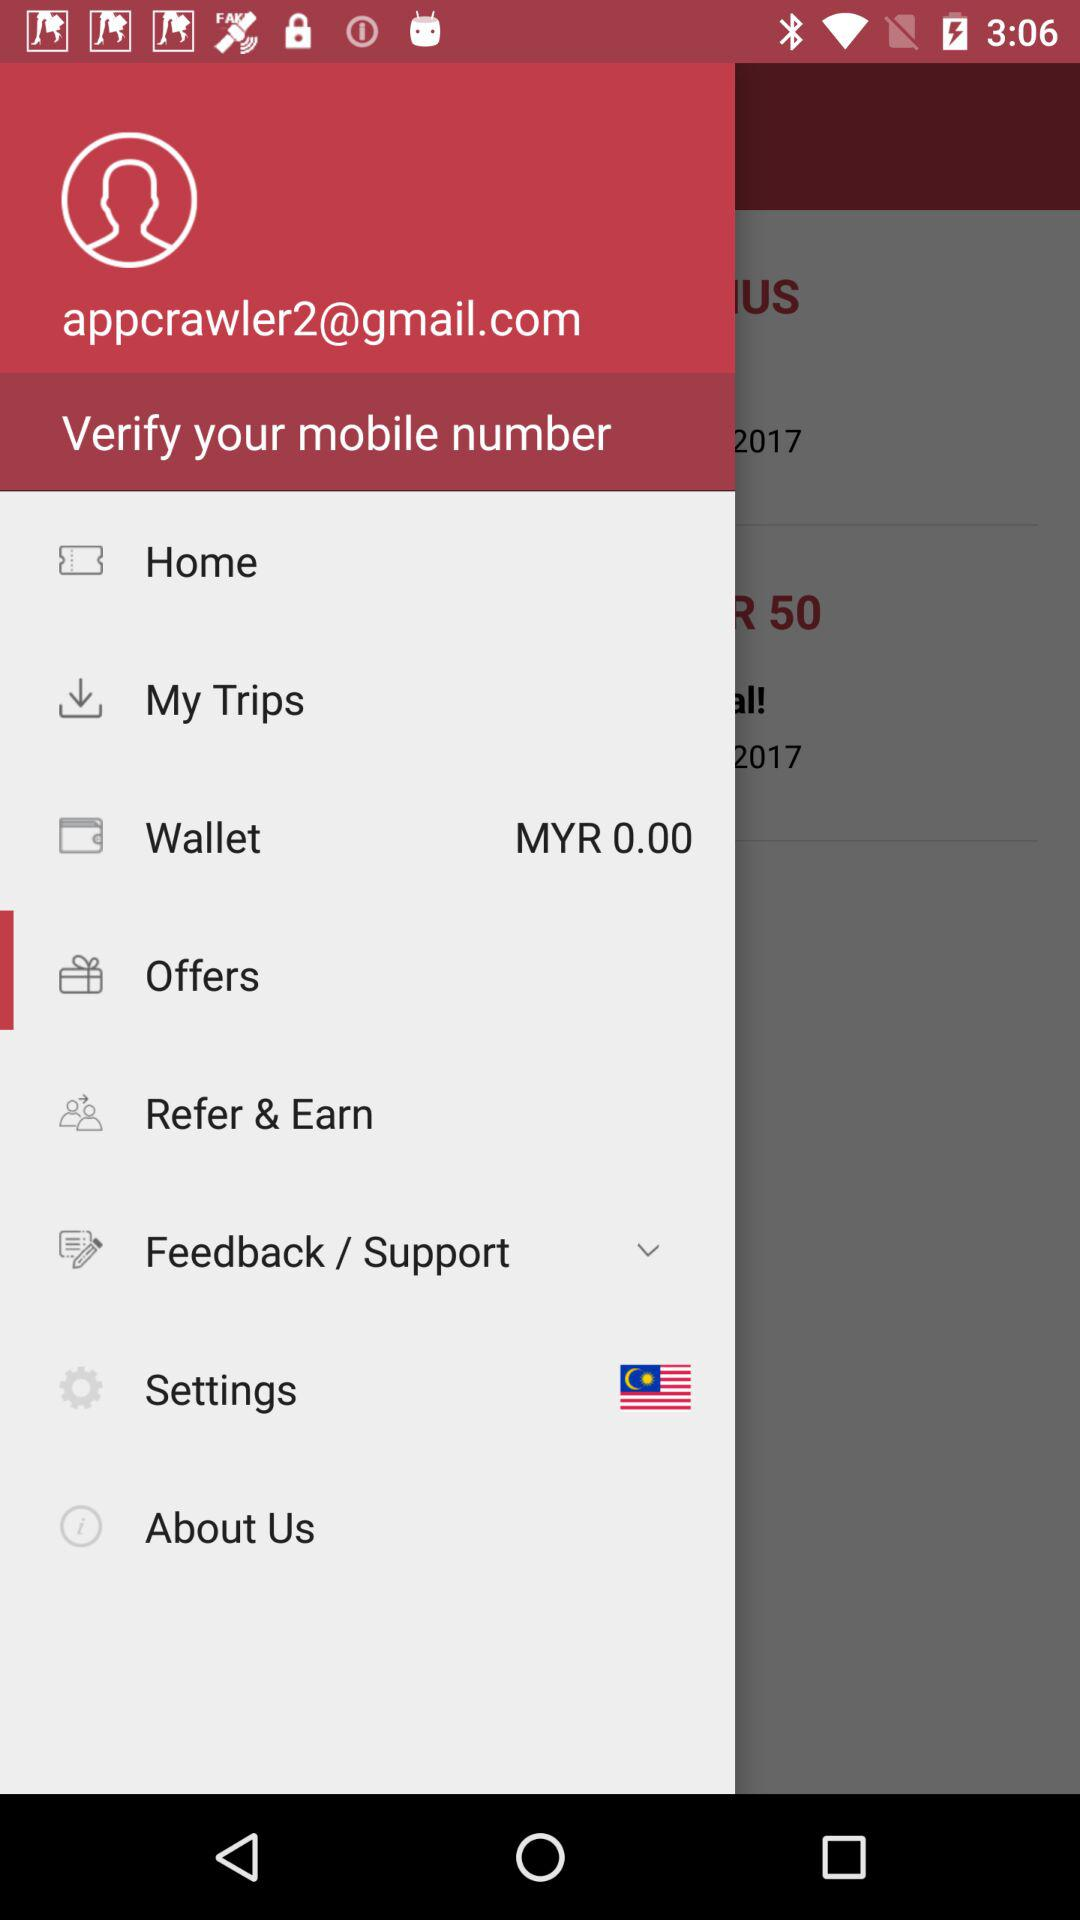What is the email id of the user? The email address is appcrawler2@gmail.com. 